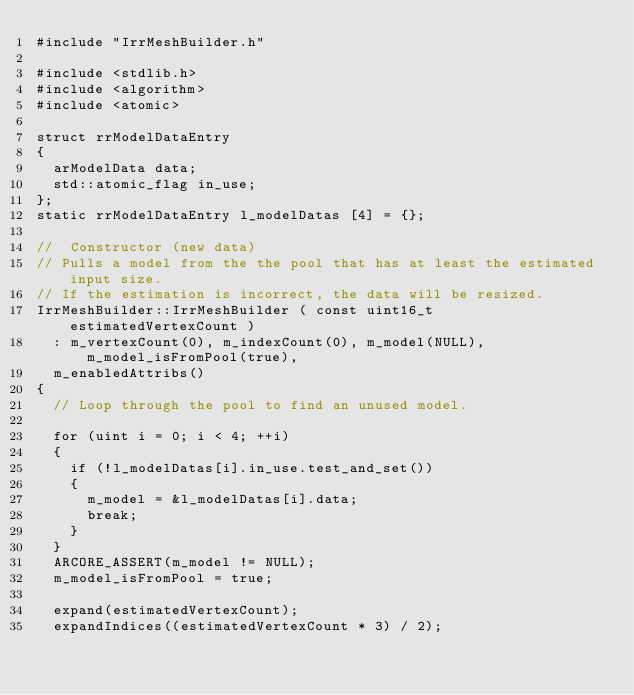Convert code to text. <code><loc_0><loc_0><loc_500><loc_500><_C++_>#include "IrrMeshBuilder.h"

#include <stdlib.h>
#include <algorithm>
#include <atomic>

struct rrModelDataEntry
{
	arModelData data;
	std::atomic_flag in_use;
};
static rrModelDataEntry l_modelDatas [4] = {};

//	Constructor (new data)
// Pulls a model from the the pool that has at least the estimated input size.
// If the estimation is incorrect, the data will be resized.
IrrMeshBuilder::IrrMeshBuilder ( const uint16_t estimatedVertexCount )
	: m_vertexCount(0), m_indexCount(0), m_model(NULL), m_model_isFromPool(true),
	m_enabledAttribs()
{
	// Loop through the pool to find an unused model.

	for (uint i = 0; i < 4; ++i)
	{
		if (!l_modelDatas[i].in_use.test_and_set())
		{
			m_model = &l_modelDatas[i].data;
			break;
		}
	}
	ARCORE_ASSERT(m_model != NULL);
	m_model_isFromPool = true;

	expand(estimatedVertexCount);
	expandIndices((estimatedVertexCount * 3) / 2);
</code> 